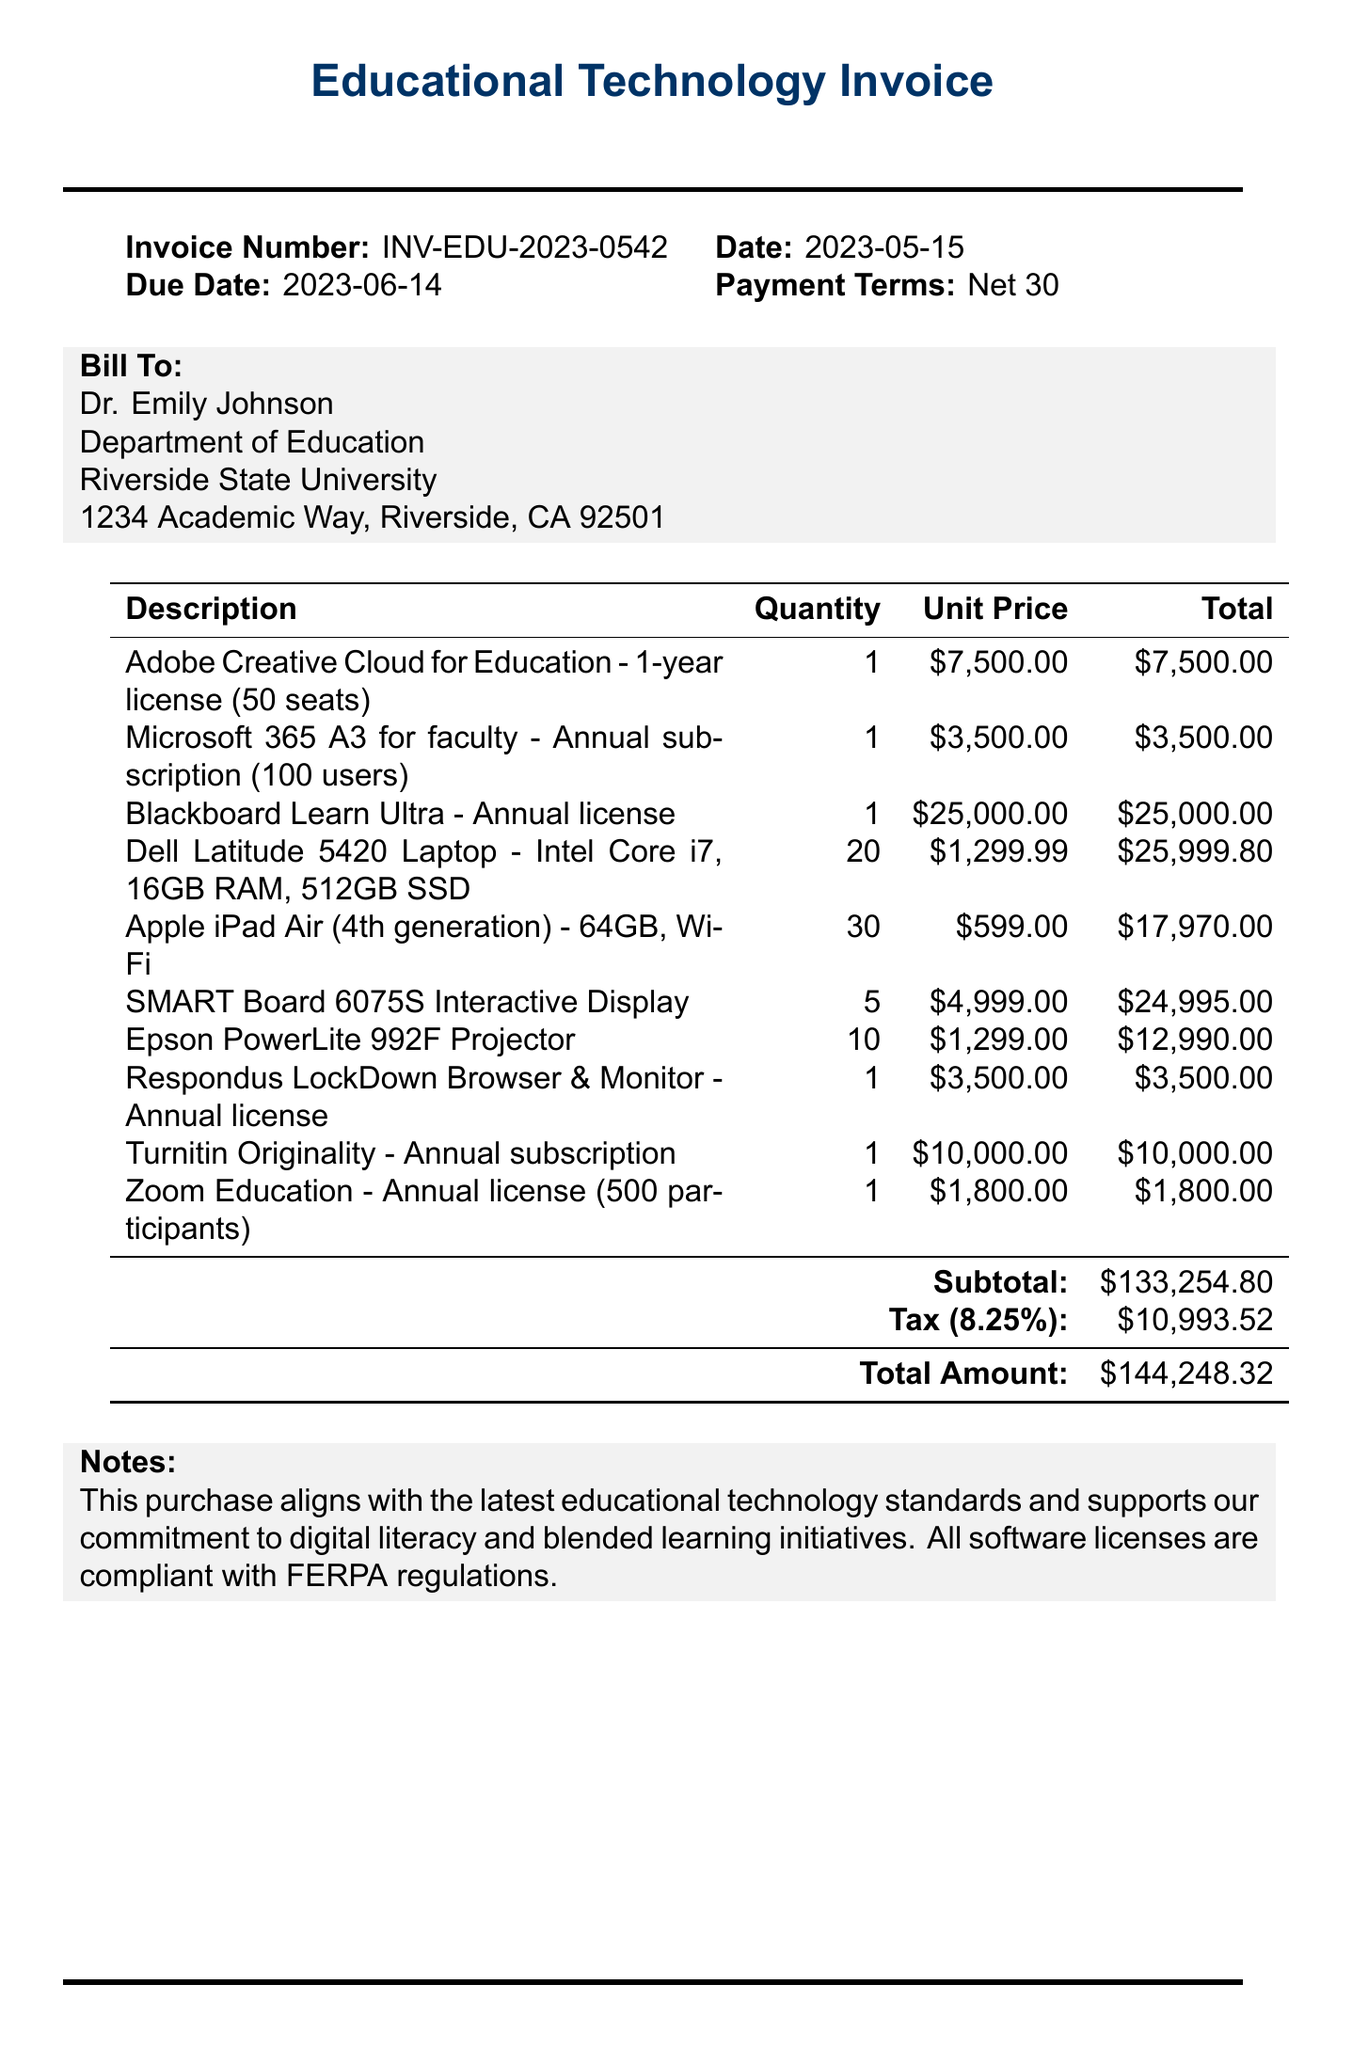What is the invoice number? The invoice number is listed at the top of the document as INV-EDU-2023-0542.
Answer: INV-EDU-2023-0542 Who is the bill to? The document states that the bill is addressed to Dr. Emily Johnson, from the Department of Education at Riverside State University.
Answer: Dr. Emily Johnson What is the due date of the invoice? The due date is given in the document as 2023-06-14.
Answer: 2023-06-14 What is the subtotal amount? The subtotal amount is detailed in the document as $133,254.80.
Answer: $133,254.80 How many Dell Latitude laptops were purchased? The number of Dell Latitude laptops is specified in the document, indicating that 20 units were included in the purchase.
Answer: 20 What is the tax rate applied? The document shows that the tax rate applied is 8.25%.
Answer: 8.25% What is the total amount due? The total amount due is clearly indicated in the document as $144,248.32.
Answer: $144,248.32 How many Apple iPad Air units were ordered? The document specifies that 30 units of Apple iPad Air were ordered.
Answer: 30 What type of payment terms is specified in the invoice? The payment terms are stated as Net 30 in the document.
Answer: Net 30 